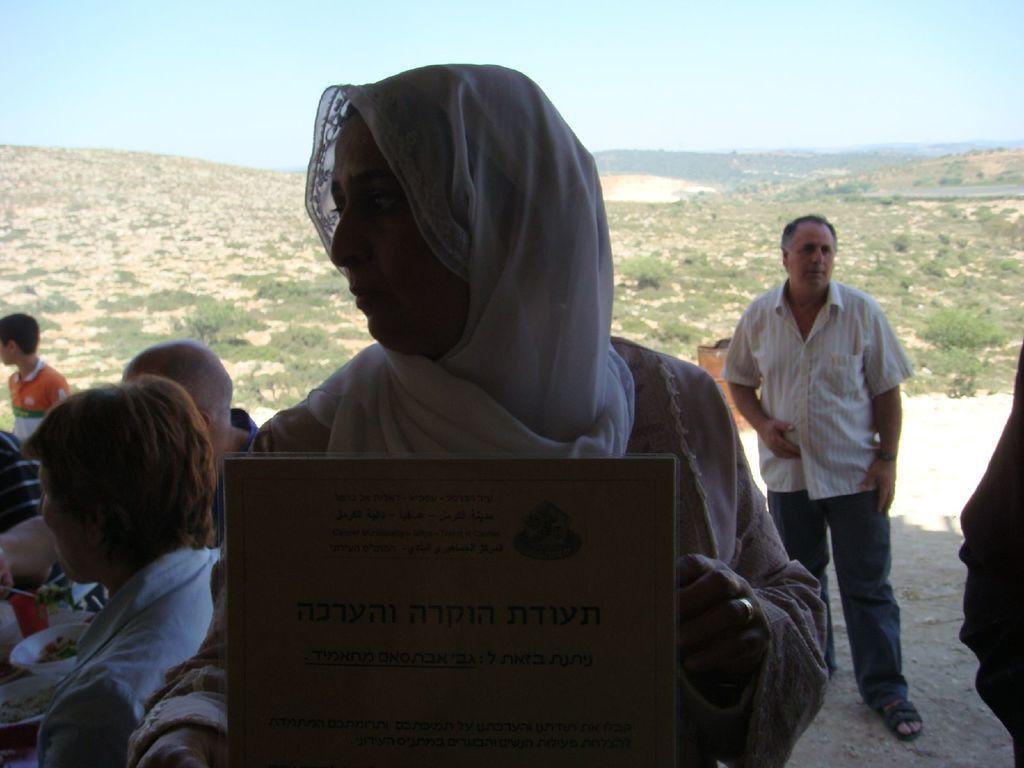Could you give a brief overview of what you see in this image? In this picture I can see there is a woman and she is holding a board and in the backdrop there are few people sitting on the table and having meals and in the backdrop there are mountains and the sky is clear. 